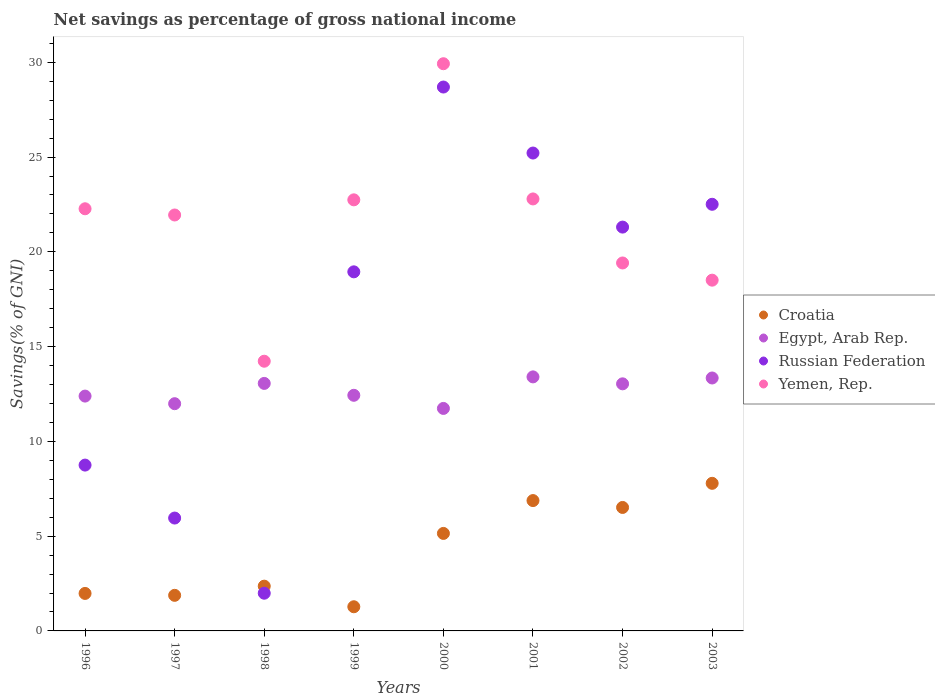How many different coloured dotlines are there?
Ensure brevity in your answer.  4. What is the total savings in Yemen, Rep. in 2001?
Give a very brief answer. 22.79. Across all years, what is the maximum total savings in Yemen, Rep.?
Your answer should be very brief. 29.92. Across all years, what is the minimum total savings in Egypt, Arab Rep.?
Offer a very short reply. 11.74. What is the total total savings in Yemen, Rep. in the graph?
Make the answer very short. 171.82. What is the difference between the total savings in Yemen, Rep. in 1996 and that in 2002?
Your response must be concise. 2.86. What is the difference between the total savings in Russian Federation in 1997 and the total savings in Yemen, Rep. in 2001?
Provide a succinct answer. -16.84. What is the average total savings in Yemen, Rep. per year?
Give a very brief answer. 21.48. In the year 2002, what is the difference between the total savings in Yemen, Rep. and total savings in Russian Federation?
Your answer should be compact. -1.89. What is the ratio of the total savings in Yemen, Rep. in 1998 to that in 2002?
Ensure brevity in your answer.  0.73. What is the difference between the highest and the second highest total savings in Croatia?
Ensure brevity in your answer.  0.91. What is the difference between the highest and the lowest total savings in Russian Federation?
Your answer should be very brief. 26.71. In how many years, is the total savings in Croatia greater than the average total savings in Croatia taken over all years?
Your answer should be very brief. 4. Is the sum of the total savings in Egypt, Arab Rep. in 1999 and 2001 greater than the maximum total savings in Yemen, Rep. across all years?
Provide a succinct answer. No. Is the total savings in Croatia strictly greater than the total savings in Yemen, Rep. over the years?
Your response must be concise. No. What is the difference between two consecutive major ticks on the Y-axis?
Give a very brief answer. 5. Are the values on the major ticks of Y-axis written in scientific E-notation?
Make the answer very short. No. Where does the legend appear in the graph?
Provide a short and direct response. Center right. How are the legend labels stacked?
Keep it short and to the point. Vertical. What is the title of the graph?
Offer a very short reply. Net savings as percentage of gross national income. What is the label or title of the X-axis?
Provide a short and direct response. Years. What is the label or title of the Y-axis?
Ensure brevity in your answer.  Savings(% of GNI). What is the Savings(% of GNI) in Croatia in 1996?
Give a very brief answer. 1.98. What is the Savings(% of GNI) in Egypt, Arab Rep. in 1996?
Your answer should be compact. 12.39. What is the Savings(% of GNI) of Russian Federation in 1996?
Give a very brief answer. 8.75. What is the Savings(% of GNI) of Yemen, Rep. in 1996?
Give a very brief answer. 22.27. What is the Savings(% of GNI) in Croatia in 1997?
Offer a terse response. 1.88. What is the Savings(% of GNI) of Egypt, Arab Rep. in 1997?
Provide a succinct answer. 11.99. What is the Savings(% of GNI) of Russian Federation in 1997?
Give a very brief answer. 5.96. What is the Savings(% of GNI) of Yemen, Rep. in 1997?
Your answer should be compact. 21.94. What is the Savings(% of GNI) in Croatia in 1998?
Your answer should be very brief. 2.36. What is the Savings(% of GNI) of Egypt, Arab Rep. in 1998?
Offer a very short reply. 13.06. What is the Savings(% of GNI) in Russian Federation in 1998?
Your answer should be very brief. 1.99. What is the Savings(% of GNI) of Yemen, Rep. in 1998?
Provide a short and direct response. 14.23. What is the Savings(% of GNI) in Croatia in 1999?
Give a very brief answer. 1.28. What is the Savings(% of GNI) of Egypt, Arab Rep. in 1999?
Your answer should be compact. 12.43. What is the Savings(% of GNI) in Russian Federation in 1999?
Your answer should be very brief. 18.94. What is the Savings(% of GNI) in Yemen, Rep. in 1999?
Make the answer very short. 22.74. What is the Savings(% of GNI) in Croatia in 2000?
Your answer should be very brief. 5.14. What is the Savings(% of GNI) in Egypt, Arab Rep. in 2000?
Provide a succinct answer. 11.74. What is the Savings(% of GNI) in Russian Federation in 2000?
Give a very brief answer. 28.69. What is the Savings(% of GNI) in Yemen, Rep. in 2000?
Make the answer very short. 29.92. What is the Savings(% of GNI) of Croatia in 2001?
Give a very brief answer. 6.88. What is the Savings(% of GNI) of Egypt, Arab Rep. in 2001?
Give a very brief answer. 13.4. What is the Savings(% of GNI) in Russian Federation in 2001?
Offer a terse response. 25.21. What is the Savings(% of GNI) in Yemen, Rep. in 2001?
Your response must be concise. 22.79. What is the Savings(% of GNI) in Croatia in 2002?
Provide a succinct answer. 6.51. What is the Savings(% of GNI) in Egypt, Arab Rep. in 2002?
Keep it short and to the point. 13.04. What is the Savings(% of GNI) of Russian Federation in 2002?
Provide a succinct answer. 21.31. What is the Savings(% of GNI) in Yemen, Rep. in 2002?
Your answer should be compact. 19.41. What is the Savings(% of GNI) in Croatia in 2003?
Your response must be concise. 7.79. What is the Savings(% of GNI) of Egypt, Arab Rep. in 2003?
Ensure brevity in your answer.  13.34. What is the Savings(% of GNI) of Russian Federation in 2003?
Your answer should be very brief. 22.51. What is the Savings(% of GNI) of Yemen, Rep. in 2003?
Keep it short and to the point. 18.51. Across all years, what is the maximum Savings(% of GNI) in Croatia?
Your response must be concise. 7.79. Across all years, what is the maximum Savings(% of GNI) of Egypt, Arab Rep.?
Keep it short and to the point. 13.4. Across all years, what is the maximum Savings(% of GNI) in Russian Federation?
Your answer should be compact. 28.69. Across all years, what is the maximum Savings(% of GNI) in Yemen, Rep.?
Give a very brief answer. 29.92. Across all years, what is the minimum Savings(% of GNI) in Croatia?
Offer a very short reply. 1.28. Across all years, what is the minimum Savings(% of GNI) in Egypt, Arab Rep.?
Your response must be concise. 11.74. Across all years, what is the minimum Savings(% of GNI) of Russian Federation?
Your answer should be very brief. 1.99. Across all years, what is the minimum Savings(% of GNI) of Yemen, Rep.?
Provide a succinct answer. 14.23. What is the total Savings(% of GNI) of Croatia in the graph?
Ensure brevity in your answer.  33.81. What is the total Savings(% of GNI) in Egypt, Arab Rep. in the graph?
Provide a short and direct response. 101.39. What is the total Savings(% of GNI) of Russian Federation in the graph?
Give a very brief answer. 133.36. What is the total Savings(% of GNI) in Yemen, Rep. in the graph?
Your answer should be compact. 171.82. What is the difference between the Savings(% of GNI) of Croatia in 1996 and that in 1997?
Give a very brief answer. 0.1. What is the difference between the Savings(% of GNI) in Egypt, Arab Rep. in 1996 and that in 1997?
Your answer should be compact. 0.4. What is the difference between the Savings(% of GNI) of Russian Federation in 1996 and that in 1997?
Make the answer very short. 2.79. What is the difference between the Savings(% of GNI) in Yemen, Rep. in 1996 and that in 1997?
Make the answer very short. 0.33. What is the difference between the Savings(% of GNI) of Croatia in 1996 and that in 1998?
Offer a terse response. -0.38. What is the difference between the Savings(% of GNI) of Egypt, Arab Rep. in 1996 and that in 1998?
Your answer should be very brief. -0.67. What is the difference between the Savings(% of GNI) in Russian Federation in 1996 and that in 1998?
Provide a short and direct response. 6.76. What is the difference between the Savings(% of GNI) of Yemen, Rep. in 1996 and that in 1998?
Offer a terse response. 8.04. What is the difference between the Savings(% of GNI) in Croatia in 1996 and that in 1999?
Your answer should be compact. 0.7. What is the difference between the Savings(% of GNI) of Egypt, Arab Rep. in 1996 and that in 1999?
Your response must be concise. -0.04. What is the difference between the Savings(% of GNI) in Russian Federation in 1996 and that in 1999?
Offer a terse response. -10.2. What is the difference between the Savings(% of GNI) in Yemen, Rep. in 1996 and that in 1999?
Provide a succinct answer. -0.47. What is the difference between the Savings(% of GNI) in Croatia in 1996 and that in 2000?
Give a very brief answer. -3.17. What is the difference between the Savings(% of GNI) in Egypt, Arab Rep. in 1996 and that in 2000?
Your response must be concise. 0.65. What is the difference between the Savings(% of GNI) of Russian Federation in 1996 and that in 2000?
Offer a very short reply. -19.95. What is the difference between the Savings(% of GNI) of Yemen, Rep. in 1996 and that in 2000?
Keep it short and to the point. -7.65. What is the difference between the Savings(% of GNI) of Croatia in 1996 and that in 2001?
Make the answer very short. -4.9. What is the difference between the Savings(% of GNI) in Egypt, Arab Rep. in 1996 and that in 2001?
Offer a very short reply. -1.01. What is the difference between the Savings(% of GNI) of Russian Federation in 1996 and that in 2001?
Offer a terse response. -16.46. What is the difference between the Savings(% of GNI) of Yemen, Rep. in 1996 and that in 2001?
Offer a very short reply. -0.52. What is the difference between the Savings(% of GNI) in Croatia in 1996 and that in 2002?
Make the answer very short. -4.54. What is the difference between the Savings(% of GNI) in Egypt, Arab Rep. in 1996 and that in 2002?
Make the answer very short. -0.65. What is the difference between the Savings(% of GNI) of Russian Federation in 1996 and that in 2002?
Make the answer very short. -12.56. What is the difference between the Savings(% of GNI) in Yemen, Rep. in 1996 and that in 2002?
Give a very brief answer. 2.86. What is the difference between the Savings(% of GNI) in Croatia in 1996 and that in 2003?
Provide a succinct answer. -5.81. What is the difference between the Savings(% of GNI) in Egypt, Arab Rep. in 1996 and that in 2003?
Your response must be concise. -0.95. What is the difference between the Savings(% of GNI) of Russian Federation in 1996 and that in 2003?
Keep it short and to the point. -13.76. What is the difference between the Savings(% of GNI) in Yemen, Rep. in 1996 and that in 2003?
Give a very brief answer. 3.77. What is the difference between the Savings(% of GNI) in Croatia in 1997 and that in 1998?
Your answer should be very brief. -0.48. What is the difference between the Savings(% of GNI) in Egypt, Arab Rep. in 1997 and that in 1998?
Keep it short and to the point. -1.07. What is the difference between the Savings(% of GNI) of Russian Federation in 1997 and that in 1998?
Your answer should be very brief. 3.97. What is the difference between the Savings(% of GNI) in Yemen, Rep. in 1997 and that in 1998?
Offer a terse response. 7.71. What is the difference between the Savings(% of GNI) of Croatia in 1997 and that in 1999?
Offer a very short reply. 0.6. What is the difference between the Savings(% of GNI) of Egypt, Arab Rep. in 1997 and that in 1999?
Make the answer very short. -0.44. What is the difference between the Savings(% of GNI) of Russian Federation in 1997 and that in 1999?
Ensure brevity in your answer.  -12.99. What is the difference between the Savings(% of GNI) of Yemen, Rep. in 1997 and that in 1999?
Keep it short and to the point. -0.8. What is the difference between the Savings(% of GNI) of Croatia in 1997 and that in 2000?
Make the answer very short. -3.27. What is the difference between the Savings(% of GNI) of Egypt, Arab Rep. in 1997 and that in 2000?
Make the answer very short. 0.25. What is the difference between the Savings(% of GNI) of Russian Federation in 1997 and that in 2000?
Offer a terse response. -22.74. What is the difference between the Savings(% of GNI) of Yemen, Rep. in 1997 and that in 2000?
Give a very brief answer. -7.98. What is the difference between the Savings(% of GNI) of Croatia in 1997 and that in 2001?
Offer a very short reply. -5. What is the difference between the Savings(% of GNI) in Egypt, Arab Rep. in 1997 and that in 2001?
Your response must be concise. -1.41. What is the difference between the Savings(% of GNI) in Russian Federation in 1997 and that in 2001?
Provide a short and direct response. -19.26. What is the difference between the Savings(% of GNI) of Yemen, Rep. in 1997 and that in 2001?
Your answer should be compact. -0.85. What is the difference between the Savings(% of GNI) in Croatia in 1997 and that in 2002?
Your answer should be very brief. -4.64. What is the difference between the Savings(% of GNI) of Egypt, Arab Rep. in 1997 and that in 2002?
Your answer should be compact. -1.05. What is the difference between the Savings(% of GNI) of Russian Federation in 1997 and that in 2002?
Your answer should be very brief. -15.35. What is the difference between the Savings(% of GNI) of Yemen, Rep. in 1997 and that in 2002?
Make the answer very short. 2.53. What is the difference between the Savings(% of GNI) in Croatia in 1997 and that in 2003?
Ensure brevity in your answer.  -5.91. What is the difference between the Savings(% of GNI) of Egypt, Arab Rep. in 1997 and that in 2003?
Give a very brief answer. -1.36. What is the difference between the Savings(% of GNI) of Russian Federation in 1997 and that in 2003?
Keep it short and to the point. -16.55. What is the difference between the Savings(% of GNI) of Yemen, Rep. in 1997 and that in 2003?
Offer a terse response. 3.44. What is the difference between the Savings(% of GNI) of Croatia in 1998 and that in 1999?
Provide a short and direct response. 1.09. What is the difference between the Savings(% of GNI) in Egypt, Arab Rep. in 1998 and that in 1999?
Give a very brief answer. 0.63. What is the difference between the Savings(% of GNI) of Russian Federation in 1998 and that in 1999?
Your response must be concise. -16.96. What is the difference between the Savings(% of GNI) in Yemen, Rep. in 1998 and that in 1999?
Ensure brevity in your answer.  -8.51. What is the difference between the Savings(% of GNI) in Croatia in 1998 and that in 2000?
Make the answer very short. -2.78. What is the difference between the Savings(% of GNI) in Egypt, Arab Rep. in 1998 and that in 2000?
Offer a terse response. 1.32. What is the difference between the Savings(% of GNI) of Russian Federation in 1998 and that in 2000?
Ensure brevity in your answer.  -26.71. What is the difference between the Savings(% of GNI) in Yemen, Rep. in 1998 and that in 2000?
Keep it short and to the point. -15.7. What is the difference between the Savings(% of GNI) in Croatia in 1998 and that in 2001?
Your response must be concise. -4.52. What is the difference between the Savings(% of GNI) in Egypt, Arab Rep. in 1998 and that in 2001?
Your answer should be very brief. -0.34. What is the difference between the Savings(% of GNI) of Russian Federation in 1998 and that in 2001?
Offer a very short reply. -23.22. What is the difference between the Savings(% of GNI) of Yemen, Rep. in 1998 and that in 2001?
Ensure brevity in your answer.  -8.56. What is the difference between the Savings(% of GNI) of Croatia in 1998 and that in 2002?
Ensure brevity in your answer.  -4.15. What is the difference between the Savings(% of GNI) of Egypt, Arab Rep. in 1998 and that in 2002?
Offer a terse response. 0.02. What is the difference between the Savings(% of GNI) of Russian Federation in 1998 and that in 2002?
Your answer should be compact. -19.32. What is the difference between the Savings(% of GNI) in Yemen, Rep. in 1998 and that in 2002?
Ensure brevity in your answer.  -5.18. What is the difference between the Savings(% of GNI) of Croatia in 1998 and that in 2003?
Keep it short and to the point. -5.43. What is the difference between the Savings(% of GNI) in Egypt, Arab Rep. in 1998 and that in 2003?
Provide a short and direct response. -0.29. What is the difference between the Savings(% of GNI) of Russian Federation in 1998 and that in 2003?
Keep it short and to the point. -20.52. What is the difference between the Savings(% of GNI) in Yemen, Rep. in 1998 and that in 2003?
Keep it short and to the point. -4.28. What is the difference between the Savings(% of GNI) of Croatia in 1999 and that in 2000?
Offer a terse response. -3.87. What is the difference between the Savings(% of GNI) of Egypt, Arab Rep. in 1999 and that in 2000?
Offer a very short reply. 0.69. What is the difference between the Savings(% of GNI) in Russian Federation in 1999 and that in 2000?
Your answer should be very brief. -9.75. What is the difference between the Savings(% of GNI) of Yemen, Rep. in 1999 and that in 2000?
Provide a short and direct response. -7.18. What is the difference between the Savings(% of GNI) in Croatia in 1999 and that in 2001?
Offer a very short reply. -5.6. What is the difference between the Savings(% of GNI) in Egypt, Arab Rep. in 1999 and that in 2001?
Provide a short and direct response. -0.97. What is the difference between the Savings(% of GNI) in Russian Federation in 1999 and that in 2001?
Offer a very short reply. -6.27. What is the difference between the Savings(% of GNI) in Yemen, Rep. in 1999 and that in 2001?
Your answer should be very brief. -0.05. What is the difference between the Savings(% of GNI) of Croatia in 1999 and that in 2002?
Ensure brevity in your answer.  -5.24. What is the difference between the Savings(% of GNI) in Egypt, Arab Rep. in 1999 and that in 2002?
Offer a terse response. -0.61. What is the difference between the Savings(% of GNI) of Russian Federation in 1999 and that in 2002?
Your response must be concise. -2.36. What is the difference between the Savings(% of GNI) of Yemen, Rep. in 1999 and that in 2002?
Ensure brevity in your answer.  3.33. What is the difference between the Savings(% of GNI) of Croatia in 1999 and that in 2003?
Your answer should be compact. -6.51. What is the difference between the Savings(% of GNI) in Egypt, Arab Rep. in 1999 and that in 2003?
Your response must be concise. -0.91. What is the difference between the Savings(% of GNI) in Russian Federation in 1999 and that in 2003?
Your response must be concise. -3.56. What is the difference between the Savings(% of GNI) in Yemen, Rep. in 1999 and that in 2003?
Ensure brevity in your answer.  4.24. What is the difference between the Savings(% of GNI) of Croatia in 2000 and that in 2001?
Offer a very short reply. -1.73. What is the difference between the Savings(% of GNI) in Egypt, Arab Rep. in 2000 and that in 2001?
Offer a terse response. -1.66. What is the difference between the Savings(% of GNI) of Russian Federation in 2000 and that in 2001?
Your answer should be compact. 3.48. What is the difference between the Savings(% of GNI) in Yemen, Rep. in 2000 and that in 2001?
Ensure brevity in your answer.  7.13. What is the difference between the Savings(% of GNI) in Croatia in 2000 and that in 2002?
Your answer should be very brief. -1.37. What is the difference between the Savings(% of GNI) of Egypt, Arab Rep. in 2000 and that in 2002?
Provide a short and direct response. -1.3. What is the difference between the Savings(% of GNI) in Russian Federation in 2000 and that in 2002?
Your response must be concise. 7.39. What is the difference between the Savings(% of GNI) of Yemen, Rep. in 2000 and that in 2002?
Your response must be concise. 10.51. What is the difference between the Savings(% of GNI) of Croatia in 2000 and that in 2003?
Your answer should be compact. -2.64. What is the difference between the Savings(% of GNI) of Egypt, Arab Rep. in 2000 and that in 2003?
Offer a terse response. -1.61. What is the difference between the Savings(% of GNI) of Russian Federation in 2000 and that in 2003?
Offer a very short reply. 6.19. What is the difference between the Savings(% of GNI) in Yemen, Rep. in 2000 and that in 2003?
Ensure brevity in your answer.  11.42. What is the difference between the Savings(% of GNI) of Croatia in 2001 and that in 2002?
Give a very brief answer. 0.36. What is the difference between the Savings(% of GNI) in Egypt, Arab Rep. in 2001 and that in 2002?
Your answer should be compact. 0.37. What is the difference between the Savings(% of GNI) in Russian Federation in 2001 and that in 2002?
Offer a very short reply. 3.91. What is the difference between the Savings(% of GNI) in Yemen, Rep. in 2001 and that in 2002?
Offer a very short reply. 3.38. What is the difference between the Savings(% of GNI) in Croatia in 2001 and that in 2003?
Keep it short and to the point. -0.91. What is the difference between the Savings(% of GNI) in Egypt, Arab Rep. in 2001 and that in 2003?
Offer a terse response. 0.06. What is the difference between the Savings(% of GNI) in Russian Federation in 2001 and that in 2003?
Provide a succinct answer. 2.7. What is the difference between the Savings(% of GNI) of Yemen, Rep. in 2001 and that in 2003?
Ensure brevity in your answer.  4.29. What is the difference between the Savings(% of GNI) in Croatia in 2002 and that in 2003?
Provide a succinct answer. -1.27. What is the difference between the Savings(% of GNI) in Egypt, Arab Rep. in 2002 and that in 2003?
Provide a succinct answer. -0.31. What is the difference between the Savings(% of GNI) in Russian Federation in 2002 and that in 2003?
Your answer should be very brief. -1.2. What is the difference between the Savings(% of GNI) in Yemen, Rep. in 2002 and that in 2003?
Your answer should be very brief. 0.91. What is the difference between the Savings(% of GNI) in Croatia in 1996 and the Savings(% of GNI) in Egypt, Arab Rep. in 1997?
Provide a short and direct response. -10.01. What is the difference between the Savings(% of GNI) of Croatia in 1996 and the Savings(% of GNI) of Russian Federation in 1997?
Offer a terse response. -3.98. What is the difference between the Savings(% of GNI) of Croatia in 1996 and the Savings(% of GNI) of Yemen, Rep. in 1997?
Your answer should be compact. -19.97. What is the difference between the Savings(% of GNI) of Egypt, Arab Rep. in 1996 and the Savings(% of GNI) of Russian Federation in 1997?
Offer a very short reply. 6.43. What is the difference between the Savings(% of GNI) of Egypt, Arab Rep. in 1996 and the Savings(% of GNI) of Yemen, Rep. in 1997?
Your response must be concise. -9.55. What is the difference between the Savings(% of GNI) in Russian Federation in 1996 and the Savings(% of GNI) in Yemen, Rep. in 1997?
Offer a very short reply. -13.19. What is the difference between the Savings(% of GNI) of Croatia in 1996 and the Savings(% of GNI) of Egypt, Arab Rep. in 1998?
Ensure brevity in your answer.  -11.08. What is the difference between the Savings(% of GNI) in Croatia in 1996 and the Savings(% of GNI) in Russian Federation in 1998?
Provide a succinct answer. -0.01. What is the difference between the Savings(% of GNI) in Croatia in 1996 and the Savings(% of GNI) in Yemen, Rep. in 1998?
Give a very brief answer. -12.25. What is the difference between the Savings(% of GNI) of Egypt, Arab Rep. in 1996 and the Savings(% of GNI) of Russian Federation in 1998?
Your answer should be very brief. 10.4. What is the difference between the Savings(% of GNI) in Egypt, Arab Rep. in 1996 and the Savings(% of GNI) in Yemen, Rep. in 1998?
Give a very brief answer. -1.84. What is the difference between the Savings(% of GNI) of Russian Federation in 1996 and the Savings(% of GNI) of Yemen, Rep. in 1998?
Provide a short and direct response. -5.48. What is the difference between the Savings(% of GNI) in Croatia in 1996 and the Savings(% of GNI) in Egypt, Arab Rep. in 1999?
Make the answer very short. -10.45. What is the difference between the Savings(% of GNI) of Croatia in 1996 and the Savings(% of GNI) of Russian Federation in 1999?
Your answer should be very brief. -16.97. What is the difference between the Savings(% of GNI) in Croatia in 1996 and the Savings(% of GNI) in Yemen, Rep. in 1999?
Provide a short and direct response. -20.77. What is the difference between the Savings(% of GNI) in Egypt, Arab Rep. in 1996 and the Savings(% of GNI) in Russian Federation in 1999?
Make the answer very short. -6.56. What is the difference between the Savings(% of GNI) in Egypt, Arab Rep. in 1996 and the Savings(% of GNI) in Yemen, Rep. in 1999?
Keep it short and to the point. -10.35. What is the difference between the Savings(% of GNI) in Russian Federation in 1996 and the Savings(% of GNI) in Yemen, Rep. in 1999?
Your answer should be compact. -13.99. What is the difference between the Savings(% of GNI) in Croatia in 1996 and the Savings(% of GNI) in Egypt, Arab Rep. in 2000?
Your answer should be very brief. -9.76. What is the difference between the Savings(% of GNI) of Croatia in 1996 and the Savings(% of GNI) of Russian Federation in 2000?
Offer a very short reply. -26.72. What is the difference between the Savings(% of GNI) in Croatia in 1996 and the Savings(% of GNI) in Yemen, Rep. in 2000?
Make the answer very short. -27.95. What is the difference between the Savings(% of GNI) of Egypt, Arab Rep. in 1996 and the Savings(% of GNI) of Russian Federation in 2000?
Offer a very short reply. -16.31. What is the difference between the Savings(% of GNI) of Egypt, Arab Rep. in 1996 and the Savings(% of GNI) of Yemen, Rep. in 2000?
Ensure brevity in your answer.  -17.53. What is the difference between the Savings(% of GNI) of Russian Federation in 1996 and the Savings(% of GNI) of Yemen, Rep. in 2000?
Provide a succinct answer. -21.18. What is the difference between the Savings(% of GNI) of Croatia in 1996 and the Savings(% of GNI) of Egypt, Arab Rep. in 2001?
Provide a succinct answer. -11.42. What is the difference between the Savings(% of GNI) in Croatia in 1996 and the Savings(% of GNI) in Russian Federation in 2001?
Keep it short and to the point. -23.23. What is the difference between the Savings(% of GNI) in Croatia in 1996 and the Savings(% of GNI) in Yemen, Rep. in 2001?
Your answer should be very brief. -20.81. What is the difference between the Savings(% of GNI) of Egypt, Arab Rep. in 1996 and the Savings(% of GNI) of Russian Federation in 2001?
Make the answer very short. -12.82. What is the difference between the Savings(% of GNI) in Egypt, Arab Rep. in 1996 and the Savings(% of GNI) in Yemen, Rep. in 2001?
Provide a short and direct response. -10.4. What is the difference between the Savings(% of GNI) in Russian Federation in 1996 and the Savings(% of GNI) in Yemen, Rep. in 2001?
Provide a succinct answer. -14.04. What is the difference between the Savings(% of GNI) in Croatia in 1996 and the Savings(% of GNI) in Egypt, Arab Rep. in 2002?
Give a very brief answer. -11.06. What is the difference between the Savings(% of GNI) of Croatia in 1996 and the Savings(% of GNI) of Russian Federation in 2002?
Your answer should be very brief. -19.33. What is the difference between the Savings(% of GNI) of Croatia in 1996 and the Savings(% of GNI) of Yemen, Rep. in 2002?
Provide a succinct answer. -17.43. What is the difference between the Savings(% of GNI) in Egypt, Arab Rep. in 1996 and the Savings(% of GNI) in Russian Federation in 2002?
Give a very brief answer. -8.92. What is the difference between the Savings(% of GNI) of Egypt, Arab Rep. in 1996 and the Savings(% of GNI) of Yemen, Rep. in 2002?
Ensure brevity in your answer.  -7.02. What is the difference between the Savings(% of GNI) of Russian Federation in 1996 and the Savings(% of GNI) of Yemen, Rep. in 2002?
Give a very brief answer. -10.66. What is the difference between the Savings(% of GNI) of Croatia in 1996 and the Savings(% of GNI) of Egypt, Arab Rep. in 2003?
Provide a short and direct response. -11.37. What is the difference between the Savings(% of GNI) of Croatia in 1996 and the Savings(% of GNI) of Russian Federation in 2003?
Give a very brief answer. -20.53. What is the difference between the Savings(% of GNI) of Croatia in 1996 and the Savings(% of GNI) of Yemen, Rep. in 2003?
Ensure brevity in your answer.  -16.53. What is the difference between the Savings(% of GNI) in Egypt, Arab Rep. in 1996 and the Savings(% of GNI) in Russian Federation in 2003?
Provide a succinct answer. -10.12. What is the difference between the Savings(% of GNI) in Egypt, Arab Rep. in 1996 and the Savings(% of GNI) in Yemen, Rep. in 2003?
Ensure brevity in your answer.  -6.12. What is the difference between the Savings(% of GNI) in Russian Federation in 1996 and the Savings(% of GNI) in Yemen, Rep. in 2003?
Provide a succinct answer. -9.76. What is the difference between the Savings(% of GNI) of Croatia in 1997 and the Savings(% of GNI) of Egypt, Arab Rep. in 1998?
Your answer should be compact. -11.18. What is the difference between the Savings(% of GNI) of Croatia in 1997 and the Savings(% of GNI) of Russian Federation in 1998?
Offer a very short reply. -0.11. What is the difference between the Savings(% of GNI) in Croatia in 1997 and the Savings(% of GNI) in Yemen, Rep. in 1998?
Offer a terse response. -12.35. What is the difference between the Savings(% of GNI) of Egypt, Arab Rep. in 1997 and the Savings(% of GNI) of Russian Federation in 1998?
Ensure brevity in your answer.  10. What is the difference between the Savings(% of GNI) in Egypt, Arab Rep. in 1997 and the Savings(% of GNI) in Yemen, Rep. in 1998?
Your answer should be compact. -2.24. What is the difference between the Savings(% of GNI) of Russian Federation in 1997 and the Savings(% of GNI) of Yemen, Rep. in 1998?
Offer a very short reply. -8.27. What is the difference between the Savings(% of GNI) of Croatia in 1997 and the Savings(% of GNI) of Egypt, Arab Rep. in 1999?
Your answer should be compact. -10.55. What is the difference between the Savings(% of GNI) in Croatia in 1997 and the Savings(% of GNI) in Russian Federation in 1999?
Keep it short and to the point. -17.07. What is the difference between the Savings(% of GNI) of Croatia in 1997 and the Savings(% of GNI) of Yemen, Rep. in 1999?
Your response must be concise. -20.87. What is the difference between the Savings(% of GNI) in Egypt, Arab Rep. in 1997 and the Savings(% of GNI) in Russian Federation in 1999?
Make the answer very short. -6.96. What is the difference between the Savings(% of GNI) of Egypt, Arab Rep. in 1997 and the Savings(% of GNI) of Yemen, Rep. in 1999?
Ensure brevity in your answer.  -10.75. What is the difference between the Savings(% of GNI) of Russian Federation in 1997 and the Savings(% of GNI) of Yemen, Rep. in 1999?
Provide a short and direct response. -16.79. What is the difference between the Savings(% of GNI) in Croatia in 1997 and the Savings(% of GNI) in Egypt, Arab Rep. in 2000?
Your answer should be very brief. -9.86. What is the difference between the Savings(% of GNI) of Croatia in 1997 and the Savings(% of GNI) of Russian Federation in 2000?
Give a very brief answer. -26.82. What is the difference between the Savings(% of GNI) in Croatia in 1997 and the Savings(% of GNI) in Yemen, Rep. in 2000?
Provide a succinct answer. -28.05. What is the difference between the Savings(% of GNI) in Egypt, Arab Rep. in 1997 and the Savings(% of GNI) in Russian Federation in 2000?
Keep it short and to the point. -16.71. What is the difference between the Savings(% of GNI) in Egypt, Arab Rep. in 1997 and the Savings(% of GNI) in Yemen, Rep. in 2000?
Offer a very short reply. -17.94. What is the difference between the Savings(% of GNI) in Russian Federation in 1997 and the Savings(% of GNI) in Yemen, Rep. in 2000?
Your response must be concise. -23.97. What is the difference between the Savings(% of GNI) in Croatia in 1997 and the Savings(% of GNI) in Egypt, Arab Rep. in 2001?
Offer a terse response. -11.53. What is the difference between the Savings(% of GNI) in Croatia in 1997 and the Savings(% of GNI) in Russian Federation in 2001?
Provide a succinct answer. -23.33. What is the difference between the Savings(% of GNI) in Croatia in 1997 and the Savings(% of GNI) in Yemen, Rep. in 2001?
Your answer should be very brief. -20.91. What is the difference between the Savings(% of GNI) in Egypt, Arab Rep. in 1997 and the Savings(% of GNI) in Russian Federation in 2001?
Make the answer very short. -13.22. What is the difference between the Savings(% of GNI) in Egypt, Arab Rep. in 1997 and the Savings(% of GNI) in Yemen, Rep. in 2001?
Your answer should be compact. -10.8. What is the difference between the Savings(% of GNI) of Russian Federation in 1997 and the Savings(% of GNI) of Yemen, Rep. in 2001?
Offer a very short reply. -16.84. What is the difference between the Savings(% of GNI) of Croatia in 1997 and the Savings(% of GNI) of Egypt, Arab Rep. in 2002?
Your answer should be compact. -11.16. What is the difference between the Savings(% of GNI) in Croatia in 1997 and the Savings(% of GNI) in Russian Federation in 2002?
Your answer should be very brief. -19.43. What is the difference between the Savings(% of GNI) in Croatia in 1997 and the Savings(% of GNI) in Yemen, Rep. in 2002?
Your answer should be very brief. -17.54. What is the difference between the Savings(% of GNI) of Egypt, Arab Rep. in 1997 and the Savings(% of GNI) of Russian Federation in 2002?
Offer a very short reply. -9.32. What is the difference between the Savings(% of GNI) of Egypt, Arab Rep. in 1997 and the Savings(% of GNI) of Yemen, Rep. in 2002?
Give a very brief answer. -7.42. What is the difference between the Savings(% of GNI) of Russian Federation in 1997 and the Savings(% of GNI) of Yemen, Rep. in 2002?
Provide a succinct answer. -13.46. What is the difference between the Savings(% of GNI) in Croatia in 1997 and the Savings(% of GNI) in Egypt, Arab Rep. in 2003?
Keep it short and to the point. -11.47. What is the difference between the Savings(% of GNI) in Croatia in 1997 and the Savings(% of GNI) in Russian Federation in 2003?
Make the answer very short. -20.63. What is the difference between the Savings(% of GNI) of Croatia in 1997 and the Savings(% of GNI) of Yemen, Rep. in 2003?
Your answer should be compact. -16.63. What is the difference between the Savings(% of GNI) of Egypt, Arab Rep. in 1997 and the Savings(% of GNI) of Russian Federation in 2003?
Provide a short and direct response. -10.52. What is the difference between the Savings(% of GNI) of Egypt, Arab Rep. in 1997 and the Savings(% of GNI) of Yemen, Rep. in 2003?
Your response must be concise. -6.52. What is the difference between the Savings(% of GNI) of Russian Federation in 1997 and the Savings(% of GNI) of Yemen, Rep. in 2003?
Your answer should be very brief. -12.55. What is the difference between the Savings(% of GNI) in Croatia in 1998 and the Savings(% of GNI) in Egypt, Arab Rep. in 1999?
Ensure brevity in your answer.  -10.07. What is the difference between the Savings(% of GNI) of Croatia in 1998 and the Savings(% of GNI) of Russian Federation in 1999?
Your answer should be compact. -16.58. What is the difference between the Savings(% of GNI) in Croatia in 1998 and the Savings(% of GNI) in Yemen, Rep. in 1999?
Your answer should be very brief. -20.38. What is the difference between the Savings(% of GNI) in Egypt, Arab Rep. in 1998 and the Savings(% of GNI) in Russian Federation in 1999?
Your answer should be compact. -5.89. What is the difference between the Savings(% of GNI) in Egypt, Arab Rep. in 1998 and the Savings(% of GNI) in Yemen, Rep. in 1999?
Make the answer very short. -9.68. What is the difference between the Savings(% of GNI) of Russian Federation in 1998 and the Savings(% of GNI) of Yemen, Rep. in 1999?
Keep it short and to the point. -20.75. What is the difference between the Savings(% of GNI) in Croatia in 1998 and the Savings(% of GNI) in Egypt, Arab Rep. in 2000?
Offer a very short reply. -9.38. What is the difference between the Savings(% of GNI) of Croatia in 1998 and the Savings(% of GNI) of Russian Federation in 2000?
Give a very brief answer. -26.33. What is the difference between the Savings(% of GNI) of Croatia in 1998 and the Savings(% of GNI) of Yemen, Rep. in 2000?
Provide a succinct answer. -27.56. What is the difference between the Savings(% of GNI) in Egypt, Arab Rep. in 1998 and the Savings(% of GNI) in Russian Federation in 2000?
Make the answer very short. -15.64. What is the difference between the Savings(% of GNI) in Egypt, Arab Rep. in 1998 and the Savings(% of GNI) in Yemen, Rep. in 2000?
Provide a succinct answer. -16.87. What is the difference between the Savings(% of GNI) in Russian Federation in 1998 and the Savings(% of GNI) in Yemen, Rep. in 2000?
Ensure brevity in your answer.  -27.93. What is the difference between the Savings(% of GNI) of Croatia in 1998 and the Savings(% of GNI) of Egypt, Arab Rep. in 2001?
Provide a short and direct response. -11.04. What is the difference between the Savings(% of GNI) of Croatia in 1998 and the Savings(% of GNI) of Russian Federation in 2001?
Ensure brevity in your answer.  -22.85. What is the difference between the Savings(% of GNI) in Croatia in 1998 and the Savings(% of GNI) in Yemen, Rep. in 2001?
Provide a succinct answer. -20.43. What is the difference between the Savings(% of GNI) of Egypt, Arab Rep. in 1998 and the Savings(% of GNI) of Russian Federation in 2001?
Provide a short and direct response. -12.15. What is the difference between the Savings(% of GNI) in Egypt, Arab Rep. in 1998 and the Savings(% of GNI) in Yemen, Rep. in 2001?
Your answer should be very brief. -9.73. What is the difference between the Savings(% of GNI) of Russian Federation in 1998 and the Savings(% of GNI) of Yemen, Rep. in 2001?
Your response must be concise. -20.8. What is the difference between the Savings(% of GNI) in Croatia in 1998 and the Savings(% of GNI) in Egypt, Arab Rep. in 2002?
Give a very brief answer. -10.67. What is the difference between the Savings(% of GNI) in Croatia in 1998 and the Savings(% of GNI) in Russian Federation in 2002?
Make the answer very short. -18.94. What is the difference between the Savings(% of GNI) in Croatia in 1998 and the Savings(% of GNI) in Yemen, Rep. in 2002?
Your answer should be very brief. -17.05. What is the difference between the Savings(% of GNI) of Egypt, Arab Rep. in 1998 and the Savings(% of GNI) of Russian Federation in 2002?
Keep it short and to the point. -8.25. What is the difference between the Savings(% of GNI) in Egypt, Arab Rep. in 1998 and the Savings(% of GNI) in Yemen, Rep. in 2002?
Your answer should be compact. -6.35. What is the difference between the Savings(% of GNI) in Russian Federation in 1998 and the Savings(% of GNI) in Yemen, Rep. in 2002?
Offer a terse response. -17.42. What is the difference between the Savings(% of GNI) in Croatia in 1998 and the Savings(% of GNI) in Egypt, Arab Rep. in 2003?
Ensure brevity in your answer.  -10.98. What is the difference between the Savings(% of GNI) of Croatia in 1998 and the Savings(% of GNI) of Russian Federation in 2003?
Provide a succinct answer. -20.15. What is the difference between the Savings(% of GNI) of Croatia in 1998 and the Savings(% of GNI) of Yemen, Rep. in 2003?
Provide a succinct answer. -16.14. What is the difference between the Savings(% of GNI) of Egypt, Arab Rep. in 1998 and the Savings(% of GNI) of Russian Federation in 2003?
Offer a very short reply. -9.45. What is the difference between the Savings(% of GNI) of Egypt, Arab Rep. in 1998 and the Savings(% of GNI) of Yemen, Rep. in 2003?
Provide a succinct answer. -5.45. What is the difference between the Savings(% of GNI) of Russian Federation in 1998 and the Savings(% of GNI) of Yemen, Rep. in 2003?
Make the answer very short. -16.52. What is the difference between the Savings(% of GNI) of Croatia in 1999 and the Savings(% of GNI) of Egypt, Arab Rep. in 2000?
Keep it short and to the point. -10.46. What is the difference between the Savings(% of GNI) of Croatia in 1999 and the Savings(% of GNI) of Russian Federation in 2000?
Provide a short and direct response. -27.42. What is the difference between the Savings(% of GNI) in Croatia in 1999 and the Savings(% of GNI) in Yemen, Rep. in 2000?
Provide a short and direct response. -28.65. What is the difference between the Savings(% of GNI) in Egypt, Arab Rep. in 1999 and the Savings(% of GNI) in Russian Federation in 2000?
Provide a succinct answer. -16.26. What is the difference between the Savings(% of GNI) of Egypt, Arab Rep. in 1999 and the Savings(% of GNI) of Yemen, Rep. in 2000?
Provide a short and direct response. -17.49. What is the difference between the Savings(% of GNI) of Russian Federation in 1999 and the Savings(% of GNI) of Yemen, Rep. in 2000?
Offer a very short reply. -10.98. What is the difference between the Savings(% of GNI) in Croatia in 1999 and the Savings(% of GNI) in Egypt, Arab Rep. in 2001?
Your answer should be compact. -12.13. What is the difference between the Savings(% of GNI) of Croatia in 1999 and the Savings(% of GNI) of Russian Federation in 2001?
Offer a very short reply. -23.94. What is the difference between the Savings(% of GNI) in Croatia in 1999 and the Savings(% of GNI) in Yemen, Rep. in 2001?
Your answer should be compact. -21.52. What is the difference between the Savings(% of GNI) in Egypt, Arab Rep. in 1999 and the Savings(% of GNI) in Russian Federation in 2001?
Make the answer very short. -12.78. What is the difference between the Savings(% of GNI) of Egypt, Arab Rep. in 1999 and the Savings(% of GNI) of Yemen, Rep. in 2001?
Make the answer very short. -10.36. What is the difference between the Savings(% of GNI) of Russian Federation in 1999 and the Savings(% of GNI) of Yemen, Rep. in 2001?
Make the answer very short. -3.85. What is the difference between the Savings(% of GNI) in Croatia in 1999 and the Savings(% of GNI) in Egypt, Arab Rep. in 2002?
Provide a succinct answer. -11.76. What is the difference between the Savings(% of GNI) of Croatia in 1999 and the Savings(% of GNI) of Russian Federation in 2002?
Your answer should be very brief. -20.03. What is the difference between the Savings(% of GNI) of Croatia in 1999 and the Savings(% of GNI) of Yemen, Rep. in 2002?
Your answer should be very brief. -18.14. What is the difference between the Savings(% of GNI) in Egypt, Arab Rep. in 1999 and the Savings(% of GNI) in Russian Federation in 2002?
Your response must be concise. -8.87. What is the difference between the Savings(% of GNI) of Egypt, Arab Rep. in 1999 and the Savings(% of GNI) of Yemen, Rep. in 2002?
Offer a very short reply. -6.98. What is the difference between the Savings(% of GNI) of Russian Federation in 1999 and the Savings(% of GNI) of Yemen, Rep. in 2002?
Ensure brevity in your answer.  -0.47. What is the difference between the Savings(% of GNI) of Croatia in 1999 and the Savings(% of GNI) of Egypt, Arab Rep. in 2003?
Offer a terse response. -12.07. What is the difference between the Savings(% of GNI) of Croatia in 1999 and the Savings(% of GNI) of Russian Federation in 2003?
Make the answer very short. -21.23. What is the difference between the Savings(% of GNI) in Croatia in 1999 and the Savings(% of GNI) in Yemen, Rep. in 2003?
Make the answer very short. -17.23. What is the difference between the Savings(% of GNI) in Egypt, Arab Rep. in 1999 and the Savings(% of GNI) in Russian Federation in 2003?
Keep it short and to the point. -10.08. What is the difference between the Savings(% of GNI) of Egypt, Arab Rep. in 1999 and the Savings(% of GNI) of Yemen, Rep. in 2003?
Ensure brevity in your answer.  -6.07. What is the difference between the Savings(% of GNI) in Russian Federation in 1999 and the Savings(% of GNI) in Yemen, Rep. in 2003?
Give a very brief answer. 0.44. What is the difference between the Savings(% of GNI) in Croatia in 2000 and the Savings(% of GNI) in Egypt, Arab Rep. in 2001?
Make the answer very short. -8.26. What is the difference between the Savings(% of GNI) of Croatia in 2000 and the Savings(% of GNI) of Russian Federation in 2001?
Offer a very short reply. -20.07. What is the difference between the Savings(% of GNI) in Croatia in 2000 and the Savings(% of GNI) in Yemen, Rep. in 2001?
Give a very brief answer. -17.65. What is the difference between the Savings(% of GNI) of Egypt, Arab Rep. in 2000 and the Savings(% of GNI) of Russian Federation in 2001?
Provide a succinct answer. -13.47. What is the difference between the Savings(% of GNI) in Egypt, Arab Rep. in 2000 and the Savings(% of GNI) in Yemen, Rep. in 2001?
Provide a succinct answer. -11.05. What is the difference between the Savings(% of GNI) of Russian Federation in 2000 and the Savings(% of GNI) of Yemen, Rep. in 2001?
Provide a short and direct response. 5.9. What is the difference between the Savings(% of GNI) in Croatia in 2000 and the Savings(% of GNI) in Egypt, Arab Rep. in 2002?
Provide a succinct answer. -7.89. What is the difference between the Savings(% of GNI) of Croatia in 2000 and the Savings(% of GNI) of Russian Federation in 2002?
Make the answer very short. -16.16. What is the difference between the Savings(% of GNI) of Croatia in 2000 and the Savings(% of GNI) of Yemen, Rep. in 2002?
Offer a very short reply. -14.27. What is the difference between the Savings(% of GNI) of Egypt, Arab Rep. in 2000 and the Savings(% of GNI) of Russian Federation in 2002?
Offer a very short reply. -9.57. What is the difference between the Savings(% of GNI) of Egypt, Arab Rep. in 2000 and the Savings(% of GNI) of Yemen, Rep. in 2002?
Make the answer very short. -7.67. What is the difference between the Savings(% of GNI) in Russian Federation in 2000 and the Savings(% of GNI) in Yemen, Rep. in 2002?
Offer a very short reply. 9.28. What is the difference between the Savings(% of GNI) of Croatia in 2000 and the Savings(% of GNI) of Egypt, Arab Rep. in 2003?
Give a very brief answer. -8.2. What is the difference between the Savings(% of GNI) in Croatia in 2000 and the Savings(% of GNI) in Russian Federation in 2003?
Keep it short and to the point. -17.36. What is the difference between the Savings(% of GNI) of Croatia in 2000 and the Savings(% of GNI) of Yemen, Rep. in 2003?
Keep it short and to the point. -13.36. What is the difference between the Savings(% of GNI) of Egypt, Arab Rep. in 2000 and the Savings(% of GNI) of Russian Federation in 2003?
Keep it short and to the point. -10.77. What is the difference between the Savings(% of GNI) of Egypt, Arab Rep. in 2000 and the Savings(% of GNI) of Yemen, Rep. in 2003?
Your answer should be very brief. -6.77. What is the difference between the Savings(% of GNI) in Russian Federation in 2000 and the Savings(% of GNI) in Yemen, Rep. in 2003?
Offer a very short reply. 10.19. What is the difference between the Savings(% of GNI) of Croatia in 2001 and the Savings(% of GNI) of Egypt, Arab Rep. in 2002?
Your answer should be very brief. -6.16. What is the difference between the Savings(% of GNI) in Croatia in 2001 and the Savings(% of GNI) in Russian Federation in 2002?
Make the answer very short. -14.43. What is the difference between the Savings(% of GNI) in Croatia in 2001 and the Savings(% of GNI) in Yemen, Rep. in 2002?
Ensure brevity in your answer.  -12.54. What is the difference between the Savings(% of GNI) of Egypt, Arab Rep. in 2001 and the Savings(% of GNI) of Russian Federation in 2002?
Your response must be concise. -7.9. What is the difference between the Savings(% of GNI) in Egypt, Arab Rep. in 2001 and the Savings(% of GNI) in Yemen, Rep. in 2002?
Keep it short and to the point. -6.01. What is the difference between the Savings(% of GNI) of Russian Federation in 2001 and the Savings(% of GNI) of Yemen, Rep. in 2002?
Ensure brevity in your answer.  5.8. What is the difference between the Savings(% of GNI) of Croatia in 2001 and the Savings(% of GNI) of Egypt, Arab Rep. in 2003?
Provide a short and direct response. -6.47. What is the difference between the Savings(% of GNI) of Croatia in 2001 and the Savings(% of GNI) of Russian Federation in 2003?
Give a very brief answer. -15.63. What is the difference between the Savings(% of GNI) in Croatia in 2001 and the Savings(% of GNI) in Yemen, Rep. in 2003?
Ensure brevity in your answer.  -11.63. What is the difference between the Savings(% of GNI) of Egypt, Arab Rep. in 2001 and the Savings(% of GNI) of Russian Federation in 2003?
Provide a succinct answer. -9.11. What is the difference between the Savings(% of GNI) in Egypt, Arab Rep. in 2001 and the Savings(% of GNI) in Yemen, Rep. in 2003?
Your response must be concise. -5.1. What is the difference between the Savings(% of GNI) of Russian Federation in 2001 and the Savings(% of GNI) of Yemen, Rep. in 2003?
Give a very brief answer. 6.71. What is the difference between the Savings(% of GNI) in Croatia in 2002 and the Savings(% of GNI) in Egypt, Arab Rep. in 2003?
Ensure brevity in your answer.  -6.83. What is the difference between the Savings(% of GNI) of Croatia in 2002 and the Savings(% of GNI) of Russian Federation in 2003?
Give a very brief answer. -15.99. What is the difference between the Savings(% of GNI) in Croatia in 2002 and the Savings(% of GNI) in Yemen, Rep. in 2003?
Make the answer very short. -11.99. What is the difference between the Savings(% of GNI) in Egypt, Arab Rep. in 2002 and the Savings(% of GNI) in Russian Federation in 2003?
Your answer should be very brief. -9.47. What is the difference between the Savings(% of GNI) of Egypt, Arab Rep. in 2002 and the Savings(% of GNI) of Yemen, Rep. in 2003?
Make the answer very short. -5.47. What is the average Savings(% of GNI) in Croatia per year?
Ensure brevity in your answer.  4.23. What is the average Savings(% of GNI) in Egypt, Arab Rep. per year?
Give a very brief answer. 12.67. What is the average Savings(% of GNI) of Russian Federation per year?
Make the answer very short. 16.67. What is the average Savings(% of GNI) in Yemen, Rep. per year?
Keep it short and to the point. 21.48. In the year 1996, what is the difference between the Savings(% of GNI) of Croatia and Savings(% of GNI) of Egypt, Arab Rep.?
Offer a terse response. -10.41. In the year 1996, what is the difference between the Savings(% of GNI) of Croatia and Savings(% of GNI) of Russian Federation?
Your answer should be compact. -6.77. In the year 1996, what is the difference between the Savings(% of GNI) of Croatia and Savings(% of GNI) of Yemen, Rep.?
Your answer should be very brief. -20.29. In the year 1996, what is the difference between the Savings(% of GNI) of Egypt, Arab Rep. and Savings(% of GNI) of Russian Federation?
Keep it short and to the point. 3.64. In the year 1996, what is the difference between the Savings(% of GNI) of Egypt, Arab Rep. and Savings(% of GNI) of Yemen, Rep.?
Provide a short and direct response. -9.88. In the year 1996, what is the difference between the Savings(% of GNI) of Russian Federation and Savings(% of GNI) of Yemen, Rep.?
Give a very brief answer. -13.52. In the year 1997, what is the difference between the Savings(% of GNI) in Croatia and Savings(% of GNI) in Egypt, Arab Rep.?
Provide a short and direct response. -10.11. In the year 1997, what is the difference between the Savings(% of GNI) in Croatia and Savings(% of GNI) in Russian Federation?
Ensure brevity in your answer.  -4.08. In the year 1997, what is the difference between the Savings(% of GNI) in Croatia and Savings(% of GNI) in Yemen, Rep.?
Make the answer very short. -20.07. In the year 1997, what is the difference between the Savings(% of GNI) of Egypt, Arab Rep. and Savings(% of GNI) of Russian Federation?
Your answer should be compact. 6.03. In the year 1997, what is the difference between the Savings(% of GNI) in Egypt, Arab Rep. and Savings(% of GNI) in Yemen, Rep.?
Keep it short and to the point. -9.96. In the year 1997, what is the difference between the Savings(% of GNI) of Russian Federation and Savings(% of GNI) of Yemen, Rep.?
Keep it short and to the point. -15.99. In the year 1998, what is the difference between the Savings(% of GNI) in Croatia and Savings(% of GNI) in Egypt, Arab Rep.?
Ensure brevity in your answer.  -10.7. In the year 1998, what is the difference between the Savings(% of GNI) of Croatia and Savings(% of GNI) of Russian Federation?
Provide a short and direct response. 0.37. In the year 1998, what is the difference between the Savings(% of GNI) of Croatia and Savings(% of GNI) of Yemen, Rep.?
Make the answer very short. -11.87. In the year 1998, what is the difference between the Savings(% of GNI) of Egypt, Arab Rep. and Savings(% of GNI) of Russian Federation?
Give a very brief answer. 11.07. In the year 1998, what is the difference between the Savings(% of GNI) of Egypt, Arab Rep. and Savings(% of GNI) of Yemen, Rep.?
Offer a very short reply. -1.17. In the year 1998, what is the difference between the Savings(% of GNI) in Russian Federation and Savings(% of GNI) in Yemen, Rep.?
Your response must be concise. -12.24. In the year 1999, what is the difference between the Savings(% of GNI) in Croatia and Savings(% of GNI) in Egypt, Arab Rep.?
Keep it short and to the point. -11.16. In the year 1999, what is the difference between the Savings(% of GNI) of Croatia and Savings(% of GNI) of Russian Federation?
Provide a succinct answer. -17.67. In the year 1999, what is the difference between the Savings(% of GNI) of Croatia and Savings(% of GNI) of Yemen, Rep.?
Make the answer very short. -21.47. In the year 1999, what is the difference between the Savings(% of GNI) in Egypt, Arab Rep. and Savings(% of GNI) in Russian Federation?
Your response must be concise. -6.51. In the year 1999, what is the difference between the Savings(% of GNI) of Egypt, Arab Rep. and Savings(% of GNI) of Yemen, Rep.?
Your answer should be very brief. -10.31. In the year 1999, what is the difference between the Savings(% of GNI) of Russian Federation and Savings(% of GNI) of Yemen, Rep.?
Make the answer very short. -3.8. In the year 2000, what is the difference between the Savings(% of GNI) of Croatia and Savings(% of GNI) of Egypt, Arab Rep.?
Offer a very short reply. -6.59. In the year 2000, what is the difference between the Savings(% of GNI) of Croatia and Savings(% of GNI) of Russian Federation?
Ensure brevity in your answer.  -23.55. In the year 2000, what is the difference between the Savings(% of GNI) in Croatia and Savings(% of GNI) in Yemen, Rep.?
Offer a terse response. -24.78. In the year 2000, what is the difference between the Savings(% of GNI) of Egypt, Arab Rep. and Savings(% of GNI) of Russian Federation?
Provide a succinct answer. -16.96. In the year 2000, what is the difference between the Savings(% of GNI) in Egypt, Arab Rep. and Savings(% of GNI) in Yemen, Rep.?
Your answer should be very brief. -18.19. In the year 2000, what is the difference between the Savings(% of GNI) of Russian Federation and Savings(% of GNI) of Yemen, Rep.?
Your answer should be compact. -1.23. In the year 2001, what is the difference between the Savings(% of GNI) in Croatia and Savings(% of GNI) in Egypt, Arab Rep.?
Your answer should be very brief. -6.53. In the year 2001, what is the difference between the Savings(% of GNI) in Croatia and Savings(% of GNI) in Russian Federation?
Your answer should be very brief. -18.34. In the year 2001, what is the difference between the Savings(% of GNI) in Croatia and Savings(% of GNI) in Yemen, Rep.?
Offer a very short reply. -15.91. In the year 2001, what is the difference between the Savings(% of GNI) in Egypt, Arab Rep. and Savings(% of GNI) in Russian Federation?
Your answer should be compact. -11.81. In the year 2001, what is the difference between the Savings(% of GNI) of Egypt, Arab Rep. and Savings(% of GNI) of Yemen, Rep.?
Ensure brevity in your answer.  -9.39. In the year 2001, what is the difference between the Savings(% of GNI) in Russian Federation and Savings(% of GNI) in Yemen, Rep.?
Make the answer very short. 2.42. In the year 2002, what is the difference between the Savings(% of GNI) in Croatia and Savings(% of GNI) in Egypt, Arab Rep.?
Your response must be concise. -6.52. In the year 2002, what is the difference between the Savings(% of GNI) of Croatia and Savings(% of GNI) of Russian Federation?
Your response must be concise. -14.79. In the year 2002, what is the difference between the Savings(% of GNI) in Croatia and Savings(% of GNI) in Yemen, Rep.?
Give a very brief answer. -12.9. In the year 2002, what is the difference between the Savings(% of GNI) of Egypt, Arab Rep. and Savings(% of GNI) of Russian Federation?
Provide a short and direct response. -8.27. In the year 2002, what is the difference between the Savings(% of GNI) in Egypt, Arab Rep. and Savings(% of GNI) in Yemen, Rep.?
Offer a terse response. -6.38. In the year 2002, what is the difference between the Savings(% of GNI) of Russian Federation and Savings(% of GNI) of Yemen, Rep.?
Your answer should be compact. 1.89. In the year 2003, what is the difference between the Savings(% of GNI) of Croatia and Savings(% of GNI) of Egypt, Arab Rep.?
Provide a succinct answer. -5.56. In the year 2003, what is the difference between the Savings(% of GNI) in Croatia and Savings(% of GNI) in Russian Federation?
Your answer should be very brief. -14.72. In the year 2003, what is the difference between the Savings(% of GNI) in Croatia and Savings(% of GNI) in Yemen, Rep.?
Offer a very short reply. -10.72. In the year 2003, what is the difference between the Savings(% of GNI) of Egypt, Arab Rep. and Savings(% of GNI) of Russian Federation?
Give a very brief answer. -9.16. In the year 2003, what is the difference between the Savings(% of GNI) in Egypt, Arab Rep. and Savings(% of GNI) in Yemen, Rep.?
Offer a very short reply. -5.16. In the year 2003, what is the difference between the Savings(% of GNI) of Russian Federation and Savings(% of GNI) of Yemen, Rep.?
Offer a terse response. 4. What is the ratio of the Savings(% of GNI) of Croatia in 1996 to that in 1997?
Keep it short and to the point. 1.05. What is the ratio of the Savings(% of GNI) in Egypt, Arab Rep. in 1996 to that in 1997?
Your answer should be compact. 1.03. What is the ratio of the Savings(% of GNI) of Russian Federation in 1996 to that in 1997?
Provide a succinct answer. 1.47. What is the ratio of the Savings(% of GNI) of Croatia in 1996 to that in 1998?
Offer a very short reply. 0.84. What is the ratio of the Savings(% of GNI) in Egypt, Arab Rep. in 1996 to that in 1998?
Provide a short and direct response. 0.95. What is the ratio of the Savings(% of GNI) in Russian Federation in 1996 to that in 1998?
Keep it short and to the point. 4.4. What is the ratio of the Savings(% of GNI) of Yemen, Rep. in 1996 to that in 1998?
Keep it short and to the point. 1.57. What is the ratio of the Savings(% of GNI) in Croatia in 1996 to that in 1999?
Provide a succinct answer. 1.55. What is the ratio of the Savings(% of GNI) in Russian Federation in 1996 to that in 1999?
Your response must be concise. 0.46. What is the ratio of the Savings(% of GNI) of Yemen, Rep. in 1996 to that in 1999?
Your answer should be compact. 0.98. What is the ratio of the Savings(% of GNI) in Croatia in 1996 to that in 2000?
Your response must be concise. 0.38. What is the ratio of the Savings(% of GNI) of Egypt, Arab Rep. in 1996 to that in 2000?
Your response must be concise. 1.06. What is the ratio of the Savings(% of GNI) in Russian Federation in 1996 to that in 2000?
Offer a terse response. 0.3. What is the ratio of the Savings(% of GNI) of Yemen, Rep. in 1996 to that in 2000?
Your response must be concise. 0.74. What is the ratio of the Savings(% of GNI) in Croatia in 1996 to that in 2001?
Your response must be concise. 0.29. What is the ratio of the Savings(% of GNI) in Egypt, Arab Rep. in 1996 to that in 2001?
Your answer should be compact. 0.92. What is the ratio of the Savings(% of GNI) in Russian Federation in 1996 to that in 2001?
Offer a very short reply. 0.35. What is the ratio of the Savings(% of GNI) in Yemen, Rep. in 1996 to that in 2001?
Provide a succinct answer. 0.98. What is the ratio of the Savings(% of GNI) of Croatia in 1996 to that in 2002?
Offer a very short reply. 0.3. What is the ratio of the Savings(% of GNI) in Egypt, Arab Rep. in 1996 to that in 2002?
Provide a succinct answer. 0.95. What is the ratio of the Savings(% of GNI) of Russian Federation in 1996 to that in 2002?
Your answer should be compact. 0.41. What is the ratio of the Savings(% of GNI) in Yemen, Rep. in 1996 to that in 2002?
Make the answer very short. 1.15. What is the ratio of the Savings(% of GNI) of Croatia in 1996 to that in 2003?
Offer a terse response. 0.25. What is the ratio of the Savings(% of GNI) of Egypt, Arab Rep. in 1996 to that in 2003?
Provide a succinct answer. 0.93. What is the ratio of the Savings(% of GNI) of Russian Federation in 1996 to that in 2003?
Give a very brief answer. 0.39. What is the ratio of the Savings(% of GNI) in Yemen, Rep. in 1996 to that in 2003?
Keep it short and to the point. 1.2. What is the ratio of the Savings(% of GNI) of Croatia in 1997 to that in 1998?
Ensure brevity in your answer.  0.8. What is the ratio of the Savings(% of GNI) in Egypt, Arab Rep. in 1997 to that in 1998?
Make the answer very short. 0.92. What is the ratio of the Savings(% of GNI) of Russian Federation in 1997 to that in 1998?
Offer a very short reply. 2.99. What is the ratio of the Savings(% of GNI) of Yemen, Rep. in 1997 to that in 1998?
Ensure brevity in your answer.  1.54. What is the ratio of the Savings(% of GNI) in Croatia in 1997 to that in 1999?
Your answer should be very brief. 1.47. What is the ratio of the Savings(% of GNI) in Egypt, Arab Rep. in 1997 to that in 1999?
Your response must be concise. 0.96. What is the ratio of the Savings(% of GNI) of Russian Federation in 1997 to that in 1999?
Your answer should be very brief. 0.31. What is the ratio of the Savings(% of GNI) in Yemen, Rep. in 1997 to that in 1999?
Provide a short and direct response. 0.96. What is the ratio of the Savings(% of GNI) of Croatia in 1997 to that in 2000?
Your answer should be compact. 0.36. What is the ratio of the Savings(% of GNI) of Egypt, Arab Rep. in 1997 to that in 2000?
Your answer should be very brief. 1.02. What is the ratio of the Savings(% of GNI) of Russian Federation in 1997 to that in 2000?
Your answer should be compact. 0.21. What is the ratio of the Savings(% of GNI) of Yemen, Rep. in 1997 to that in 2000?
Provide a succinct answer. 0.73. What is the ratio of the Savings(% of GNI) in Croatia in 1997 to that in 2001?
Provide a short and direct response. 0.27. What is the ratio of the Savings(% of GNI) in Egypt, Arab Rep. in 1997 to that in 2001?
Ensure brevity in your answer.  0.89. What is the ratio of the Savings(% of GNI) in Russian Federation in 1997 to that in 2001?
Provide a succinct answer. 0.24. What is the ratio of the Savings(% of GNI) of Yemen, Rep. in 1997 to that in 2001?
Provide a short and direct response. 0.96. What is the ratio of the Savings(% of GNI) in Croatia in 1997 to that in 2002?
Make the answer very short. 0.29. What is the ratio of the Savings(% of GNI) in Egypt, Arab Rep. in 1997 to that in 2002?
Keep it short and to the point. 0.92. What is the ratio of the Savings(% of GNI) of Russian Federation in 1997 to that in 2002?
Ensure brevity in your answer.  0.28. What is the ratio of the Savings(% of GNI) of Yemen, Rep. in 1997 to that in 2002?
Your answer should be very brief. 1.13. What is the ratio of the Savings(% of GNI) in Croatia in 1997 to that in 2003?
Offer a terse response. 0.24. What is the ratio of the Savings(% of GNI) in Egypt, Arab Rep. in 1997 to that in 2003?
Provide a short and direct response. 0.9. What is the ratio of the Savings(% of GNI) in Russian Federation in 1997 to that in 2003?
Offer a terse response. 0.26. What is the ratio of the Savings(% of GNI) of Yemen, Rep. in 1997 to that in 2003?
Make the answer very short. 1.19. What is the ratio of the Savings(% of GNI) in Croatia in 1998 to that in 1999?
Your answer should be compact. 1.85. What is the ratio of the Savings(% of GNI) of Egypt, Arab Rep. in 1998 to that in 1999?
Your answer should be very brief. 1.05. What is the ratio of the Savings(% of GNI) of Russian Federation in 1998 to that in 1999?
Your answer should be very brief. 0.1. What is the ratio of the Savings(% of GNI) of Yemen, Rep. in 1998 to that in 1999?
Make the answer very short. 0.63. What is the ratio of the Savings(% of GNI) in Croatia in 1998 to that in 2000?
Give a very brief answer. 0.46. What is the ratio of the Savings(% of GNI) in Egypt, Arab Rep. in 1998 to that in 2000?
Provide a succinct answer. 1.11. What is the ratio of the Savings(% of GNI) of Russian Federation in 1998 to that in 2000?
Make the answer very short. 0.07. What is the ratio of the Savings(% of GNI) in Yemen, Rep. in 1998 to that in 2000?
Ensure brevity in your answer.  0.48. What is the ratio of the Savings(% of GNI) of Croatia in 1998 to that in 2001?
Offer a terse response. 0.34. What is the ratio of the Savings(% of GNI) in Egypt, Arab Rep. in 1998 to that in 2001?
Make the answer very short. 0.97. What is the ratio of the Savings(% of GNI) of Russian Federation in 1998 to that in 2001?
Offer a very short reply. 0.08. What is the ratio of the Savings(% of GNI) in Yemen, Rep. in 1998 to that in 2001?
Ensure brevity in your answer.  0.62. What is the ratio of the Savings(% of GNI) in Croatia in 1998 to that in 2002?
Your answer should be compact. 0.36. What is the ratio of the Savings(% of GNI) of Egypt, Arab Rep. in 1998 to that in 2002?
Your answer should be very brief. 1. What is the ratio of the Savings(% of GNI) in Russian Federation in 1998 to that in 2002?
Make the answer very short. 0.09. What is the ratio of the Savings(% of GNI) of Yemen, Rep. in 1998 to that in 2002?
Ensure brevity in your answer.  0.73. What is the ratio of the Savings(% of GNI) of Croatia in 1998 to that in 2003?
Keep it short and to the point. 0.3. What is the ratio of the Savings(% of GNI) of Egypt, Arab Rep. in 1998 to that in 2003?
Provide a succinct answer. 0.98. What is the ratio of the Savings(% of GNI) of Russian Federation in 1998 to that in 2003?
Provide a succinct answer. 0.09. What is the ratio of the Savings(% of GNI) in Yemen, Rep. in 1998 to that in 2003?
Offer a very short reply. 0.77. What is the ratio of the Savings(% of GNI) in Croatia in 1999 to that in 2000?
Your answer should be very brief. 0.25. What is the ratio of the Savings(% of GNI) in Egypt, Arab Rep. in 1999 to that in 2000?
Offer a very short reply. 1.06. What is the ratio of the Savings(% of GNI) of Russian Federation in 1999 to that in 2000?
Your answer should be very brief. 0.66. What is the ratio of the Savings(% of GNI) in Yemen, Rep. in 1999 to that in 2000?
Your answer should be compact. 0.76. What is the ratio of the Savings(% of GNI) in Croatia in 1999 to that in 2001?
Offer a very short reply. 0.19. What is the ratio of the Savings(% of GNI) of Egypt, Arab Rep. in 1999 to that in 2001?
Offer a terse response. 0.93. What is the ratio of the Savings(% of GNI) in Russian Federation in 1999 to that in 2001?
Give a very brief answer. 0.75. What is the ratio of the Savings(% of GNI) in Croatia in 1999 to that in 2002?
Offer a terse response. 0.2. What is the ratio of the Savings(% of GNI) of Egypt, Arab Rep. in 1999 to that in 2002?
Your response must be concise. 0.95. What is the ratio of the Savings(% of GNI) in Russian Federation in 1999 to that in 2002?
Your answer should be very brief. 0.89. What is the ratio of the Savings(% of GNI) in Yemen, Rep. in 1999 to that in 2002?
Offer a very short reply. 1.17. What is the ratio of the Savings(% of GNI) in Croatia in 1999 to that in 2003?
Your answer should be compact. 0.16. What is the ratio of the Savings(% of GNI) in Egypt, Arab Rep. in 1999 to that in 2003?
Make the answer very short. 0.93. What is the ratio of the Savings(% of GNI) in Russian Federation in 1999 to that in 2003?
Provide a succinct answer. 0.84. What is the ratio of the Savings(% of GNI) of Yemen, Rep. in 1999 to that in 2003?
Give a very brief answer. 1.23. What is the ratio of the Savings(% of GNI) in Croatia in 2000 to that in 2001?
Keep it short and to the point. 0.75. What is the ratio of the Savings(% of GNI) in Egypt, Arab Rep. in 2000 to that in 2001?
Offer a very short reply. 0.88. What is the ratio of the Savings(% of GNI) in Russian Federation in 2000 to that in 2001?
Make the answer very short. 1.14. What is the ratio of the Savings(% of GNI) in Yemen, Rep. in 2000 to that in 2001?
Provide a short and direct response. 1.31. What is the ratio of the Savings(% of GNI) of Croatia in 2000 to that in 2002?
Your response must be concise. 0.79. What is the ratio of the Savings(% of GNI) of Egypt, Arab Rep. in 2000 to that in 2002?
Your answer should be compact. 0.9. What is the ratio of the Savings(% of GNI) of Russian Federation in 2000 to that in 2002?
Make the answer very short. 1.35. What is the ratio of the Savings(% of GNI) of Yemen, Rep. in 2000 to that in 2002?
Your answer should be very brief. 1.54. What is the ratio of the Savings(% of GNI) in Croatia in 2000 to that in 2003?
Offer a terse response. 0.66. What is the ratio of the Savings(% of GNI) in Egypt, Arab Rep. in 2000 to that in 2003?
Offer a very short reply. 0.88. What is the ratio of the Savings(% of GNI) of Russian Federation in 2000 to that in 2003?
Provide a short and direct response. 1.27. What is the ratio of the Savings(% of GNI) of Yemen, Rep. in 2000 to that in 2003?
Offer a terse response. 1.62. What is the ratio of the Savings(% of GNI) in Croatia in 2001 to that in 2002?
Your answer should be very brief. 1.06. What is the ratio of the Savings(% of GNI) in Egypt, Arab Rep. in 2001 to that in 2002?
Provide a succinct answer. 1.03. What is the ratio of the Savings(% of GNI) in Russian Federation in 2001 to that in 2002?
Your answer should be compact. 1.18. What is the ratio of the Savings(% of GNI) in Yemen, Rep. in 2001 to that in 2002?
Your answer should be compact. 1.17. What is the ratio of the Savings(% of GNI) of Croatia in 2001 to that in 2003?
Make the answer very short. 0.88. What is the ratio of the Savings(% of GNI) of Egypt, Arab Rep. in 2001 to that in 2003?
Your answer should be compact. 1. What is the ratio of the Savings(% of GNI) of Russian Federation in 2001 to that in 2003?
Provide a short and direct response. 1.12. What is the ratio of the Savings(% of GNI) in Yemen, Rep. in 2001 to that in 2003?
Ensure brevity in your answer.  1.23. What is the ratio of the Savings(% of GNI) in Croatia in 2002 to that in 2003?
Your answer should be compact. 0.84. What is the ratio of the Savings(% of GNI) of Egypt, Arab Rep. in 2002 to that in 2003?
Provide a succinct answer. 0.98. What is the ratio of the Savings(% of GNI) in Russian Federation in 2002 to that in 2003?
Make the answer very short. 0.95. What is the ratio of the Savings(% of GNI) of Yemen, Rep. in 2002 to that in 2003?
Your answer should be very brief. 1.05. What is the difference between the highest and the second highest Savings(% of GNI) in Croatia?
Ensure brevity in your answer.  0.91. What is the difference between the highest and the second highest Savings(% of GNI) of Egypt, Arab Rep.?
Ensure brevity in your answer.  0.06. What is the difference between the highest and the second highest Savings(% of GNI) of Russian Federation?
Your answer should be very brief. 3.48. What is the difference between the highest and the second highest Savings(% of GNI) in Yemen, Rep.?
Provide a short and direct response. 7.13. What is the difference between the highest and the lowest Savings(% of GNI) in Croatia?
Make the answer very short. 6.51. What is the difference between the highest and the lowest Savings(% of GNI) of Egypt, Arab Rep.?
Keep it short and to the point. 1.66. What is the difference between the highest and the lowest Savings(% of GNI) in Russian Federation?
Provide a short and direct response. 26.71. What is the difference between the highest and the lowest Savings(% of GNI) of Yemen, Rep.?
Your answer should be compact. 15.7. 